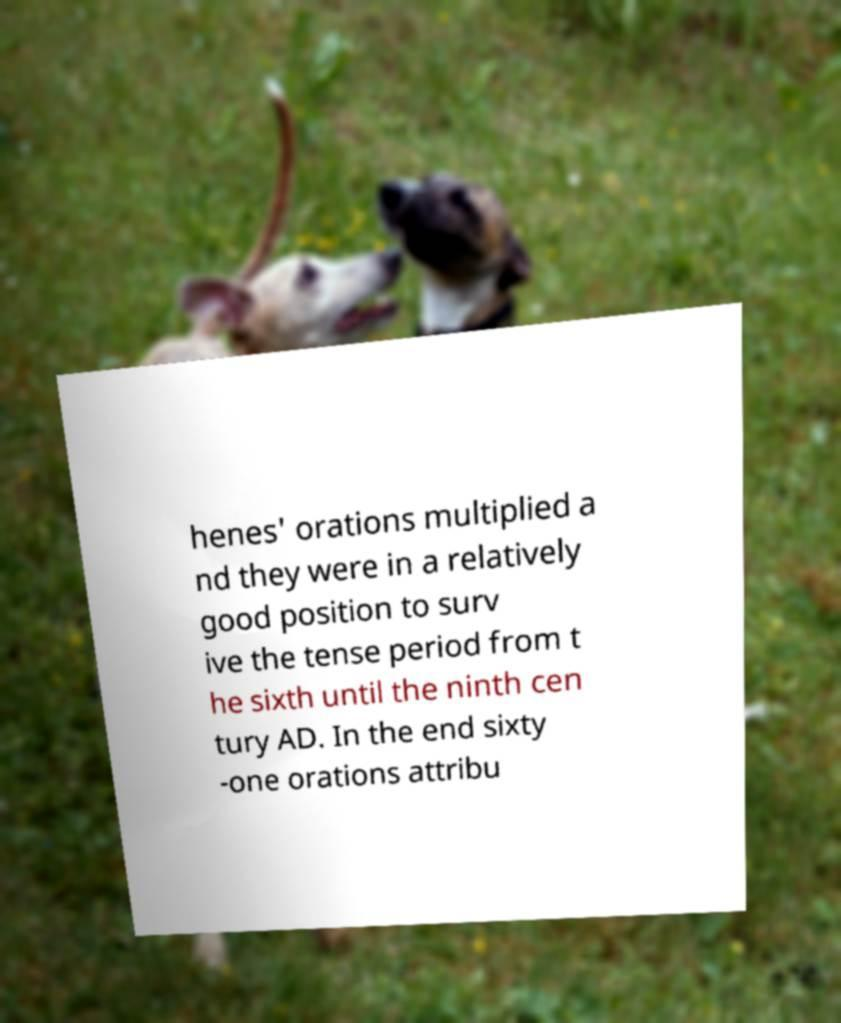Could you assist in decoding the text presented in this image and type it out clearly? henes' orations multiplied a nd they were in a relatively good position to surv ive the tense period from t he sixth until the ninth cen tury AD. In the end sixty -one orations attribu 